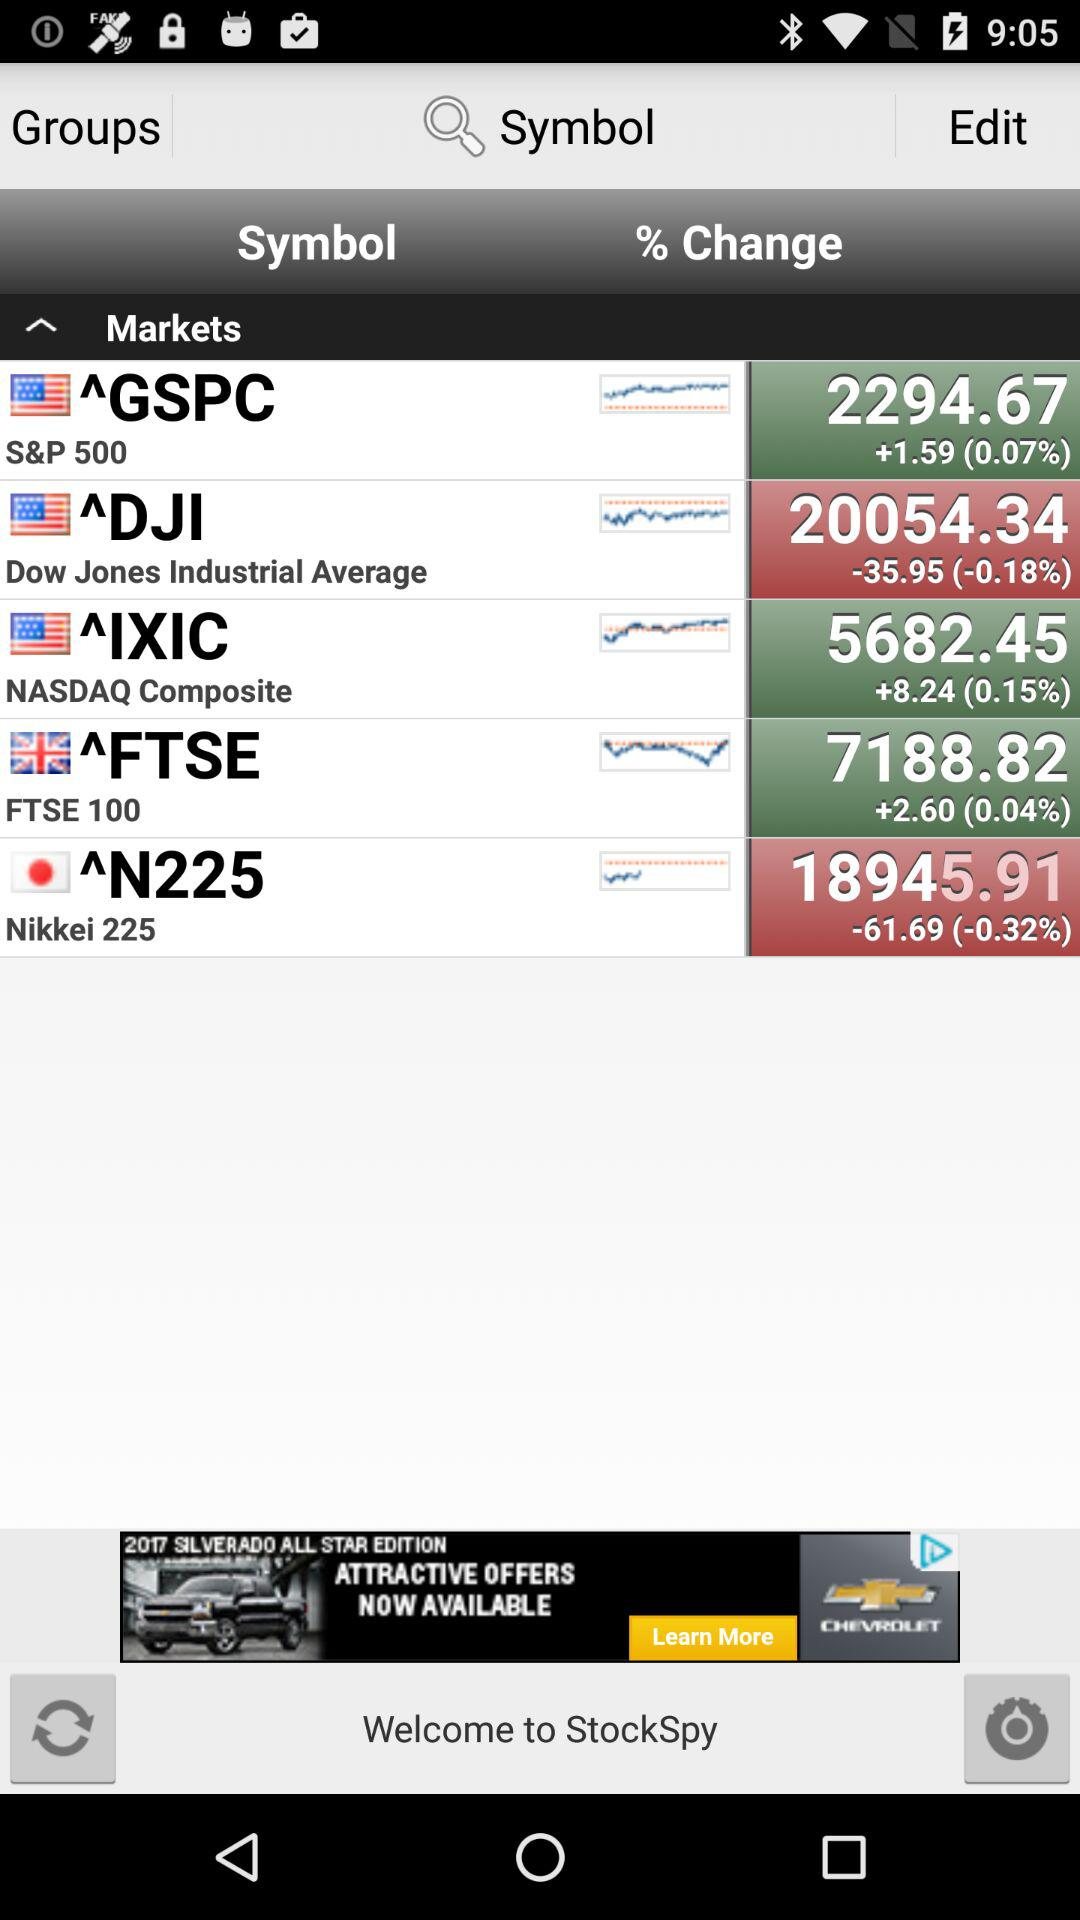What is the stock price of DJI? The stock price is 20054.34. 